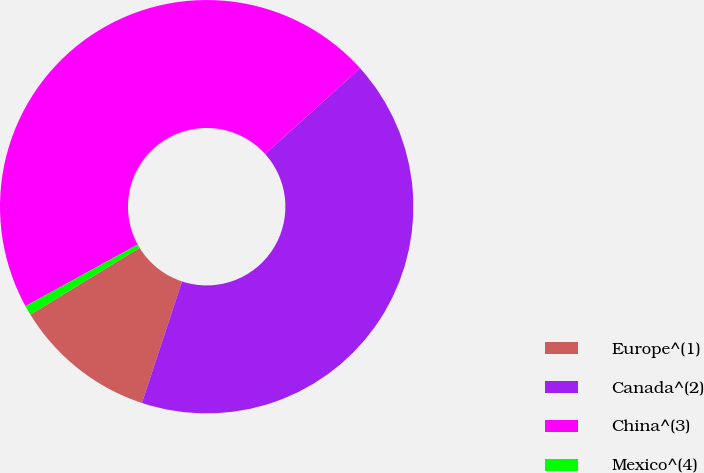Convert chart to OTSL. <chart><loc_0><loc_0><loc_500><loc_500><pie_chart><fcel>Europe^(1)<fcel>Canada^(2)<fcel>China^(3)<fcel>Mexico^(4)<nl><fcel>11.19%<fcel>41.76%<fcel>46.31%<fcel>0.75%<nl></chart> 